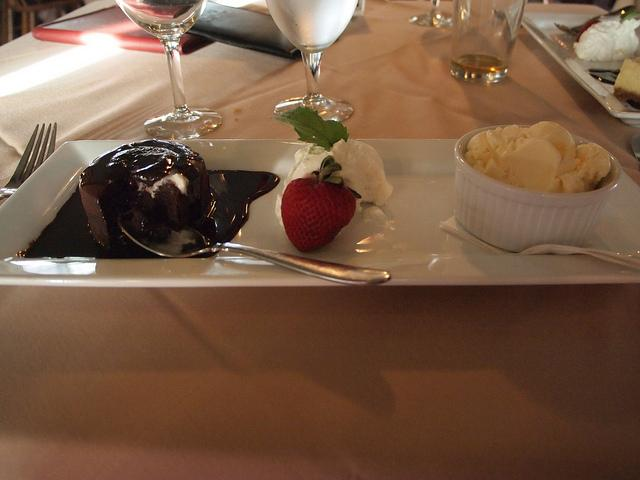What color is the chocolate on top of the white plate? dark brown 